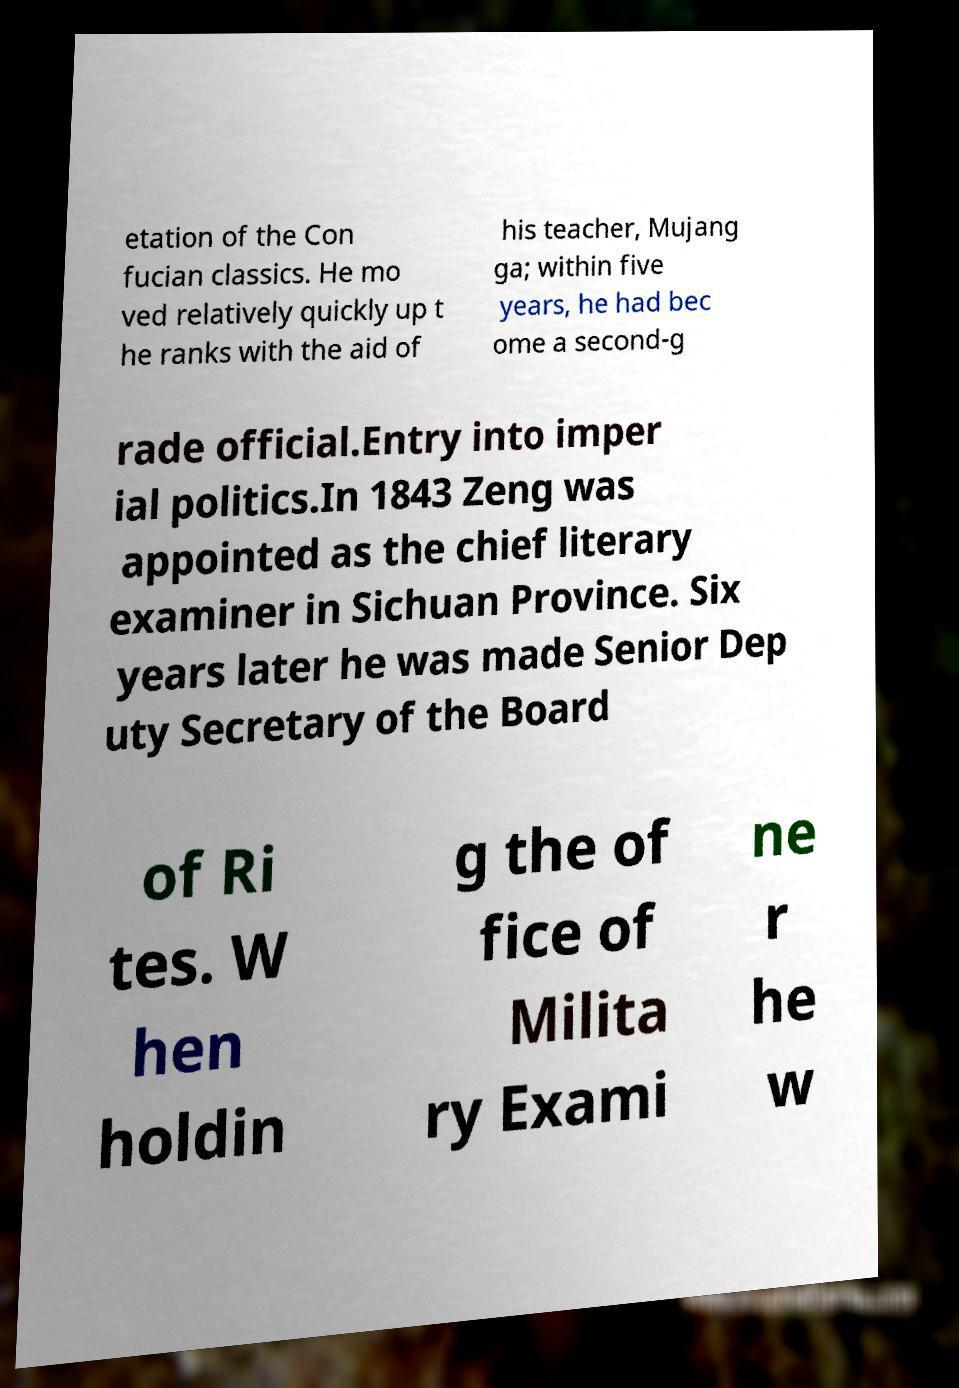For documentation purposes, I need the text within this image transcribed. Could you provide that? etation of the Con fucian classics. He mo ved relatively quickly up t he ranks with the aid of his teacher, Mujang ga; within five years, he had bec ome a second-g rade official.Entry into imper ial politics.In 1843 Zeng was appointed as the chief literary examiner in Sichuan Province. Six years later he was made Senior Dep uty Secretary of the Board of Ri tes. W hen holdin g the of fice of Milita ry Exami ne r he w 